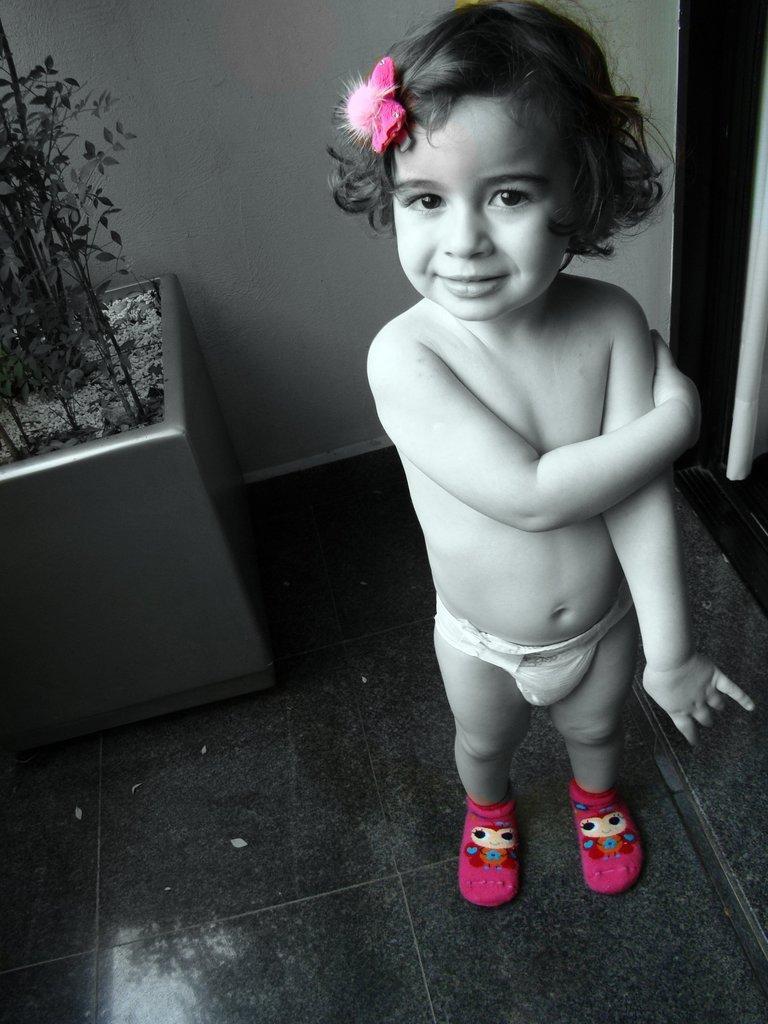In one or two sentences, can you explain what this image depicts? In this image, we can see a kid is standing on the surface, watching and smiling. Here we can see pink color hair accessory and socks. Background there is a wall. On the left side, we can see a plant with pot. Right side of the image, we can see few objects. 